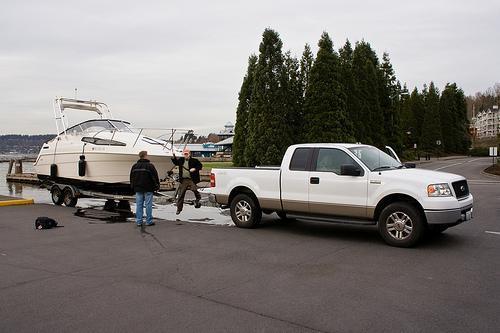How many people?
Give a very brief answer. 2. How many boats?
Give a very brief answer. 1. How many people are wearing a red coloured hat in the image?
Give a very brief answer. 1. 